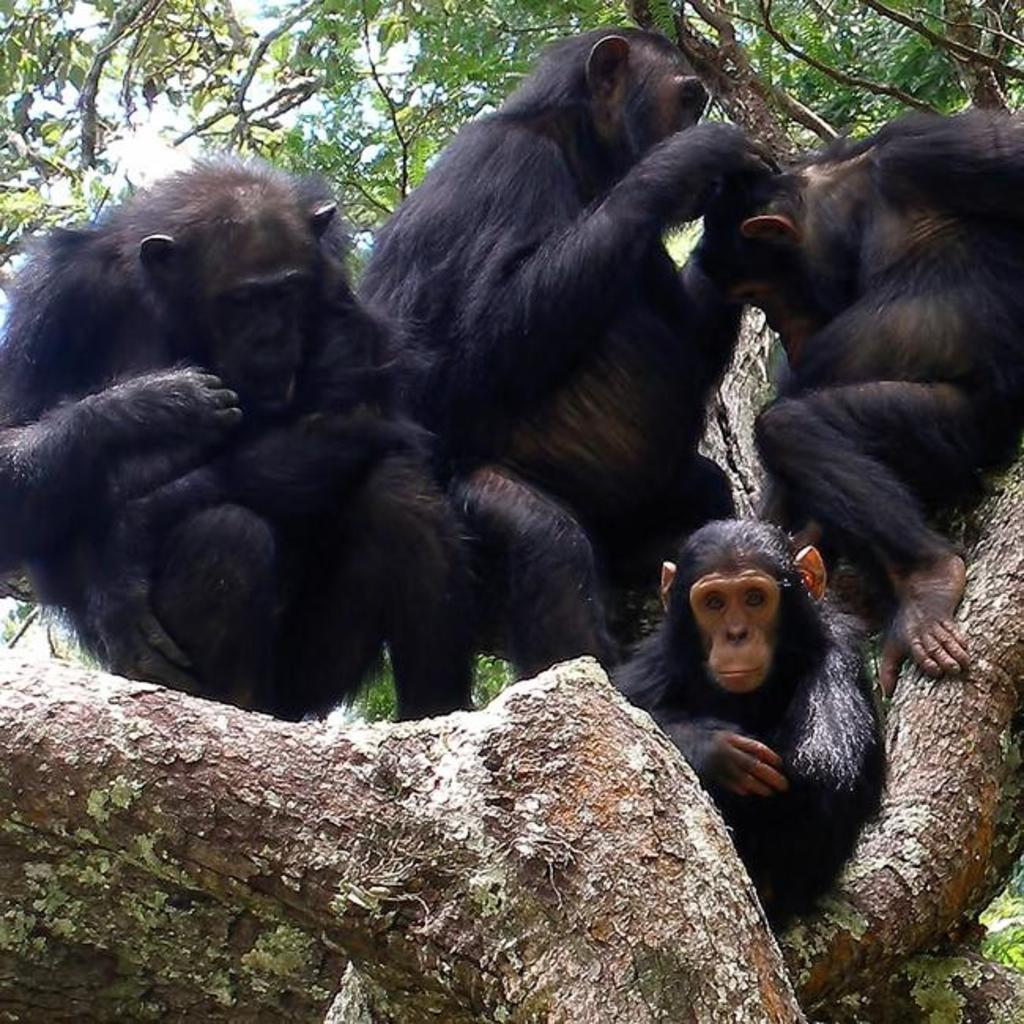How many monkeys are in the image? There are four monkeys in the image. Where are the monkeys located? The monkeys are on a tree. What can be seen in the background of the image? The sky is visible in the image. What type of environment might the image be taken in? The image is likely taken in a forest. When might the image have been taken? The image is likely taken during the day. What type of waves can be seen in the image? There are no waves present in the image; it features four monkeys on a tree in a forest setting. 